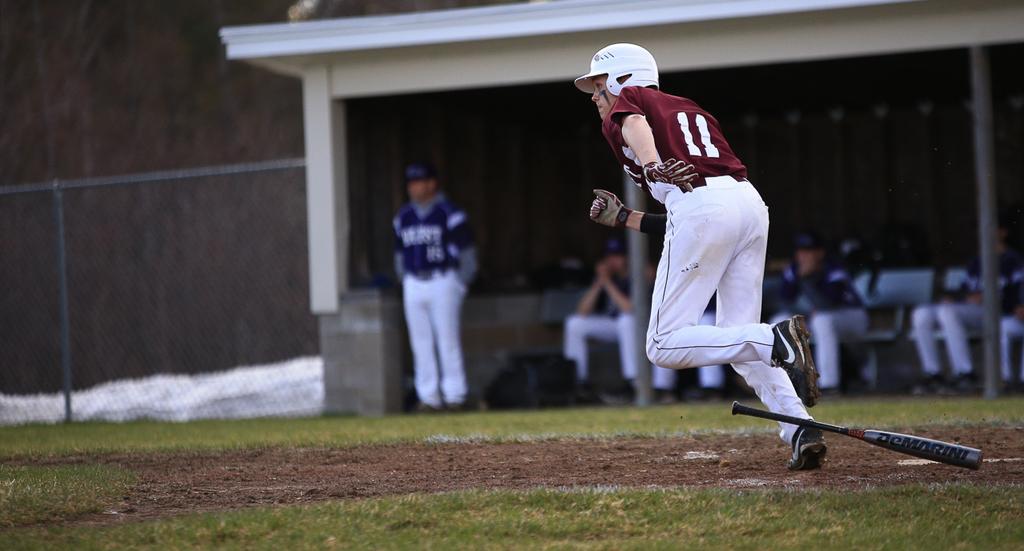In one or two sentences, can you explain what this image depicts? In this picture there is a person wearing maroon T-shirt is running and there is a base ball bat in the right corner and there is a greenery ground on either sides of him and there are few people and a fence in the background. 